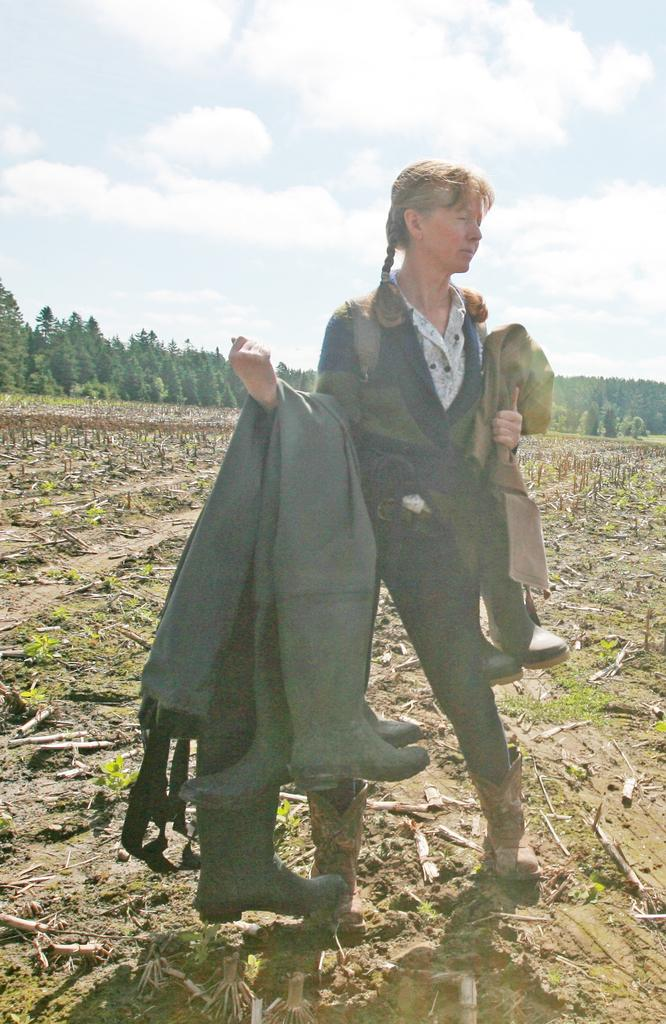What is the main subject of the image? The main subject of the image is a woman. What is the woman holding in the image? The woman is holding boots with her hands. Where is the woman standing in the image? The woman is standing on the ground. What can be seen in the background of the image? In the background of the image, there are plants, sticks, trees, and the sky. What is the condition of the sky in the image? The sky is visible in the background of the image, and clouds are present. What type of doctor can be seen examining the woman in the image? There is no doctor present in the image, and the woman is not being examined. Is there a volcano visible in the background of the image? No, there is no volcano present in the image. What type of bomb is the woman holding in the image? The woman is not holding a bomb in the image; she is holding boots. 